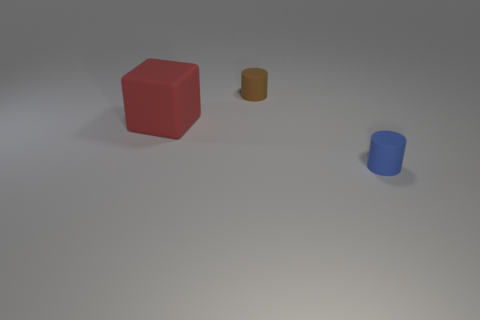There is a small cylinder that is in front of the large red rubber block; is it the same color as the small rubber object that is behind the tiny blue matte thing?
Your answer should be very brief. No. Is the number of tiny brown spheres less than the number of small brown rubber cylinders?
Provide a short and direct response. Yes. What shape is the small object left of the small rubber thing in front of the big matte cube?
Ensure brevity in your answer.  Cylinder. Is there anything else that is the same size as the rubber block?
Keep it short and to the point. No. There is a matte thing on the left side of the small cylinder that is behind the matte thing left of the tiny brown cylinder; what is its shape?
Make the answer very short. Cube. What number of things are tiny rubber cylinders that are in front of the brown matte object or cylinders behind the large red matte cube?
Ensure brevity in your answer.  2. Do the brown matte cylinder and the rubber thing in front of the red block have the same size?
Offer a very short reply. Yes. Does the cylinder that is behind the red matte object have the same material as the object that is in front of the large cube?
Make the answer very short. Yes. Are there the same number of matte things in front of the matte block and large objects that are to the right of the blue object?
Your response must be concise. No. How many rubber things are blue cylinders or brown things?
Offer a very short reply. 2. 